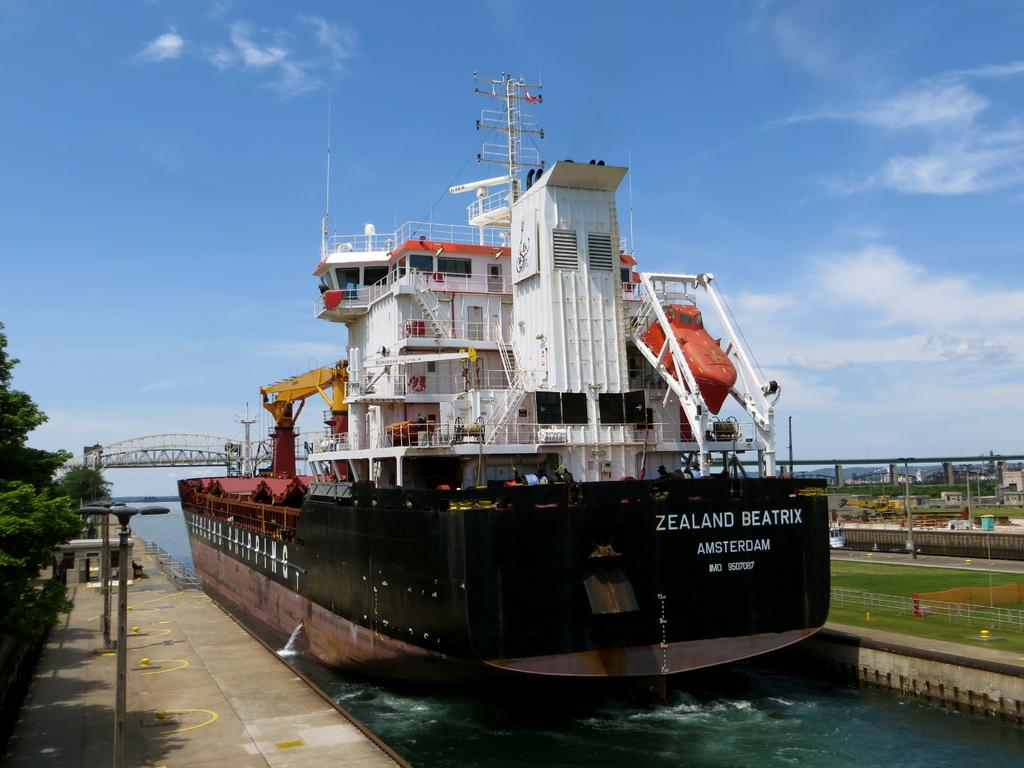<image>
Provide a brief description of the given image. Black and white ship which says ZEALAND BEATRIX on it. 